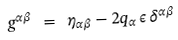<formula> <loc_0><loc_0><loc_500><loc_500>g ^ { \alpha \beta } \ = \ \eta _ { \alpha \beta } - 2 q _ { \alpha } \, \epsilon \, \delta ^ { \alpha \beta }</formula> 